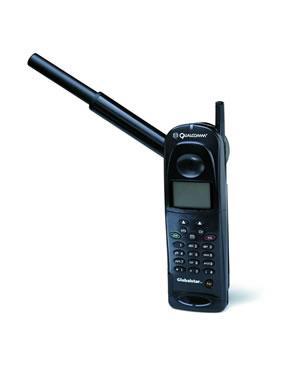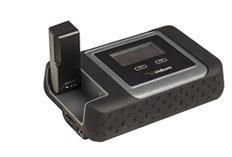The first image is the image on the left, the second image is the image on the right. For the images displayed, is the sentence "There are at least three phones." factually correct? Answer yes or no. No. The first image is the image on the left, the second image is the image on the right. For the images displayed, is the sentence "One image contains a single black device, which is upright and has a rod-shape extending diagonally from its top." factually correct? Answer yes or no. Yes. 